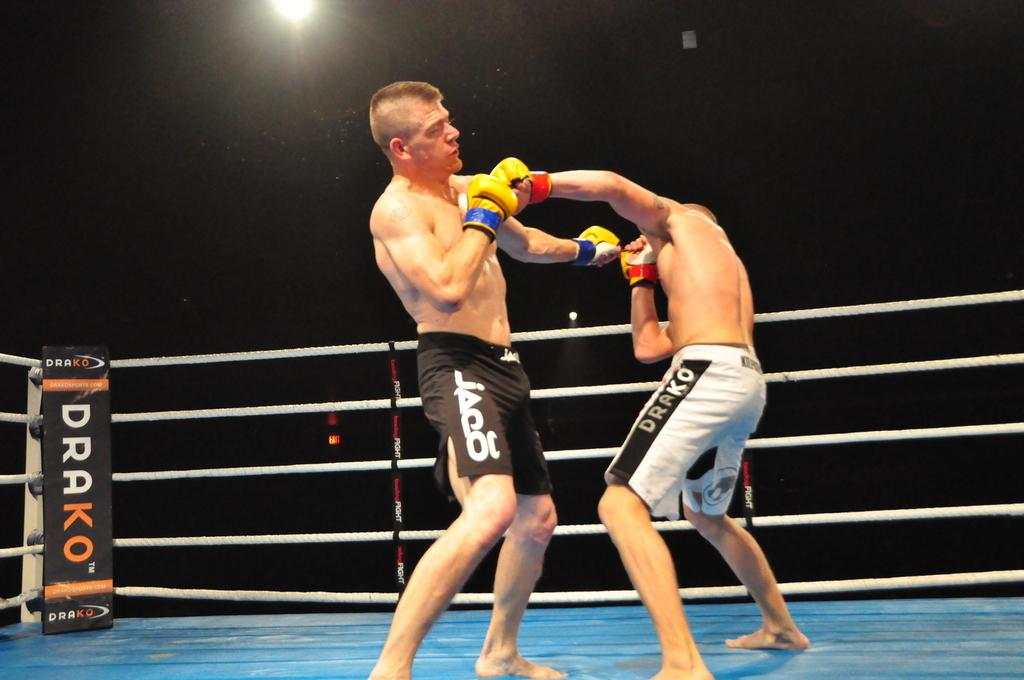<image>
Relay a brief, clear account of the picture shown. a corner of a ring that says Drako on it 